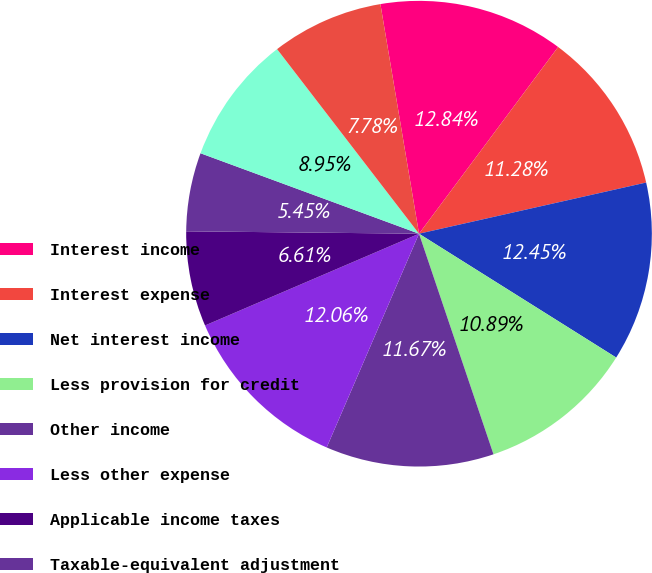Convert chart. <chart><loc_0><loc_0><loc_500><loc_500><pie_chart><fcel>Interest income<fcel>Interest expense<fcel>Net interest income<fcel>Less provision for credit<fcel>Other income<fcel>Less other expense<fcel>Applicable income taxes<fcel>Taxable-equivalent adjustment<fcel>Net income<fcel>Net income available to common<nl><fcel>12.84%<fcel>11.28%<fcel>12.45%<fcel>10.89%<fcel>11.67%<fcel>12.06%<fcel>6.61%<fcel>5.45%<fcel>8.95%<fcel>7.78%<nl></chart> 